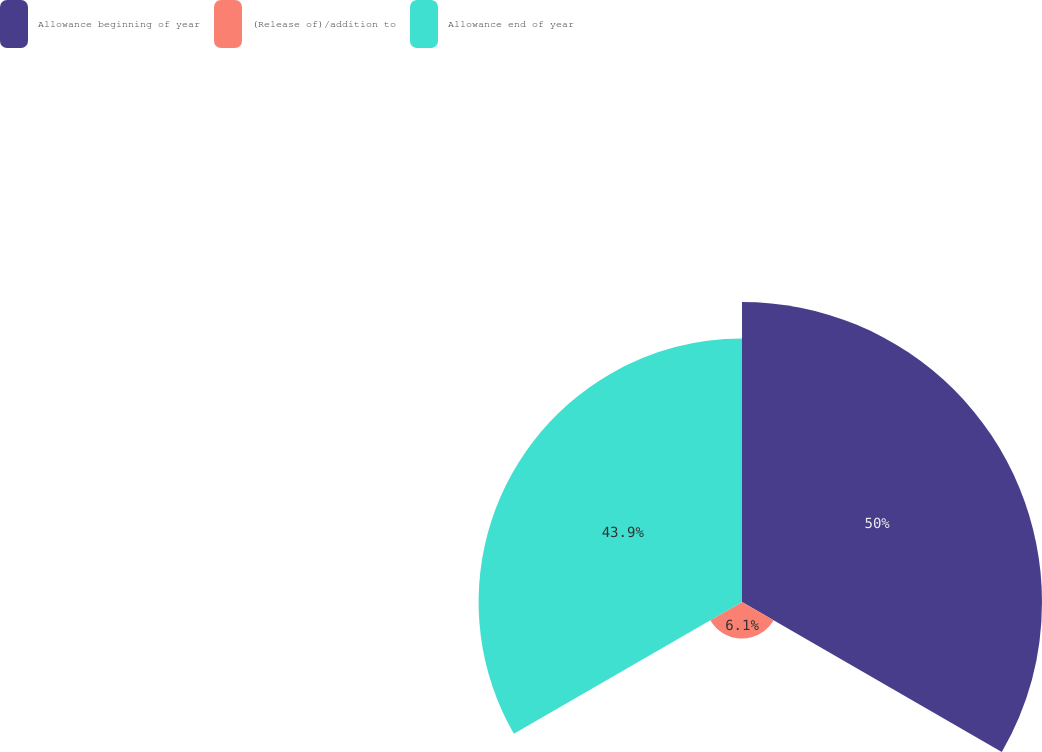Convert chart to OTSL. <chart><loc_0><loc_0><loc_500><loc_500><pie_chart><fcel>Allowance beginning of year<fcel>(Release of)/addition to<fcel>Allowance end of year<nl><fcel>50.0%<fcel>6.1%<fcel>43.9%<nl></chart> 